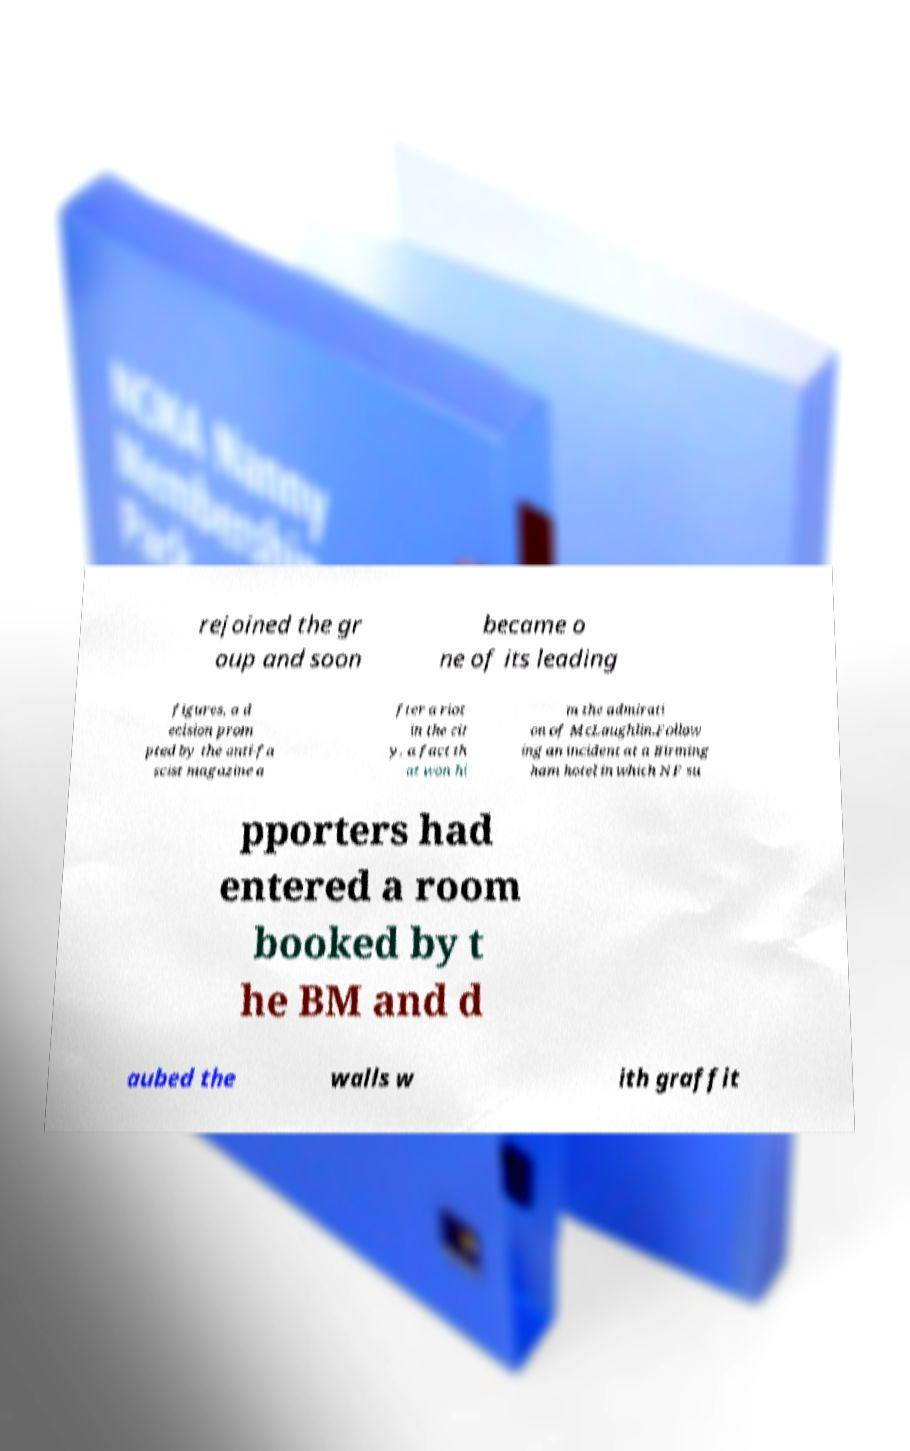Could you assist in decoding the text presented in this image and type it out clearly? rejoined the gr oup and soon became o ne of its leading figures, a d ecision prom pted by the anti-fa scist magazine a fter a riot in the cit y, a fact th at won hi m the admirati on of McLaughlin.Follow ing an incident at a Birming ham hotel in which NF su pporters had entered a room booked by t he BM and d aubed the walls w ith graffit 